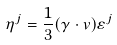<formula> <loc_0><loc_0><loc_500><loc_500>\eta ^ { j } = \frac { 1 } { 3 } ( \gamma \cdot v ) \varepsilon ^ { j }</formula> 